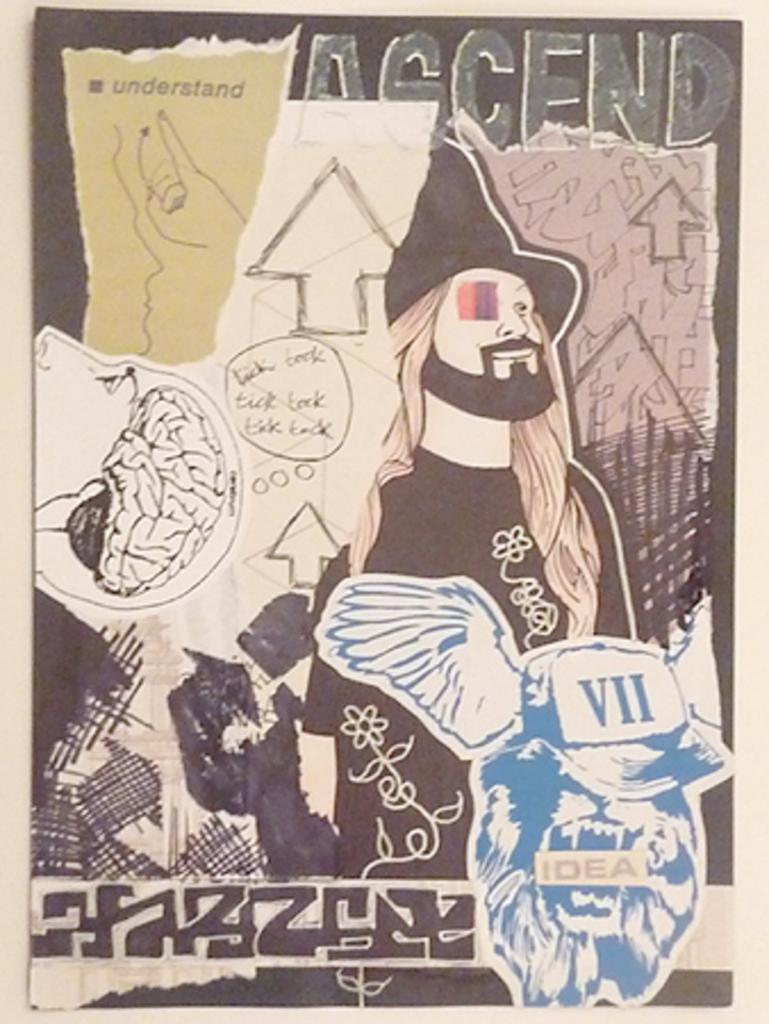In one or two sentences, can you explain what this image depicts? This picture shows poster on the board we see a cartoon pictures on it. 